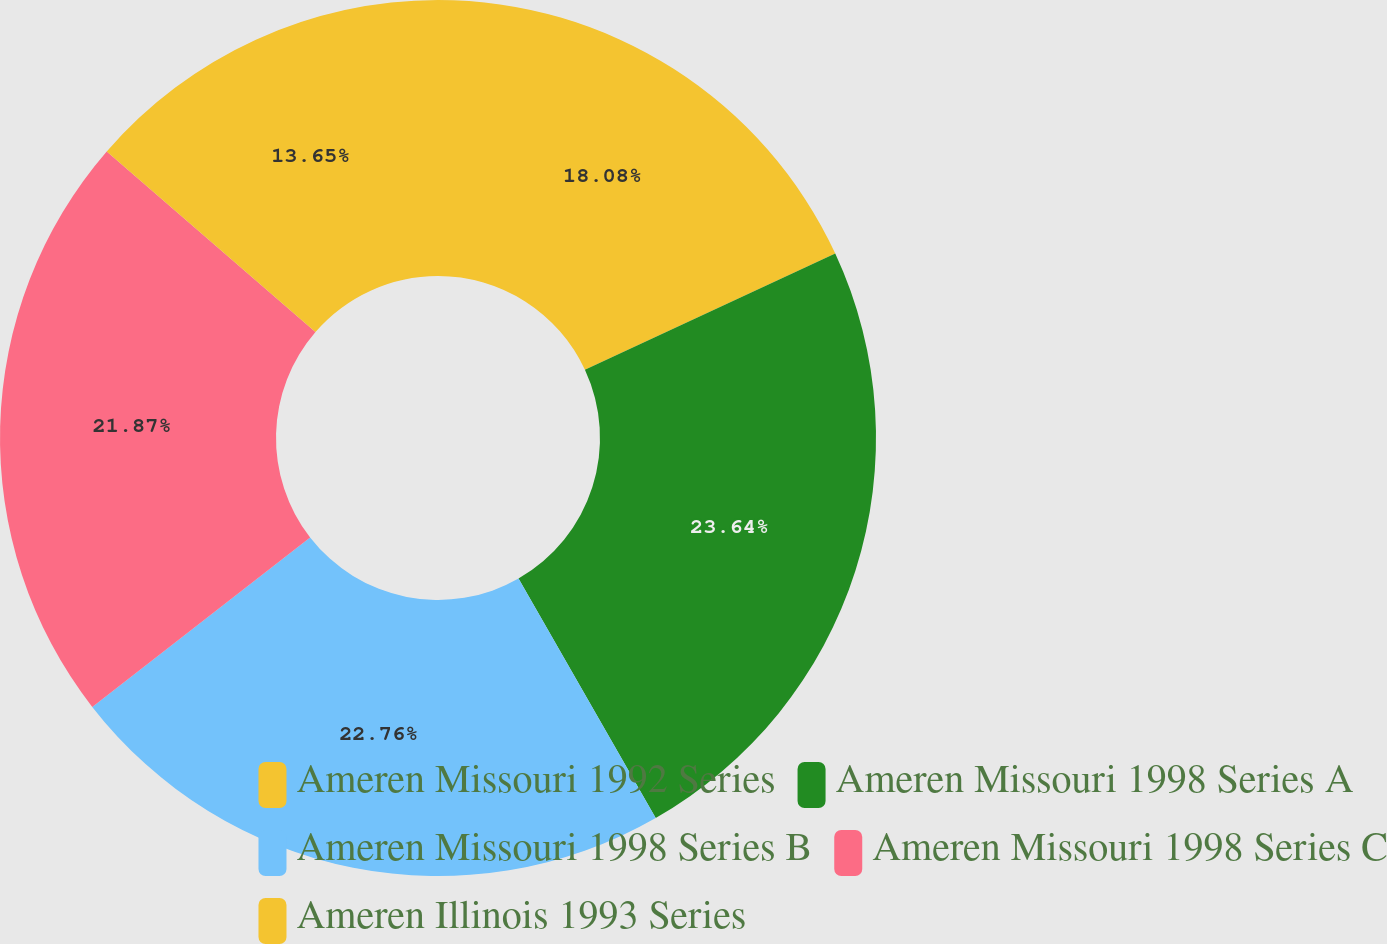Convert chart. <chart><loc_0><loc_0><loc_500><loc_500><pie_chart><fcel>Ameren Missouri 1992 Series<fcel>Ameren Missouri 1998 Series A<fcel>Ameren Missouri 1998 Series B<fcel>Ameren Missouri 1998 Series C<fcel>Ameren Illinois 1993 Series<nl><fcel>18.08%<fcel>23.64%<fcel>22.76%<fcel>21.87%<fcel>13.65%<nl></chart> 